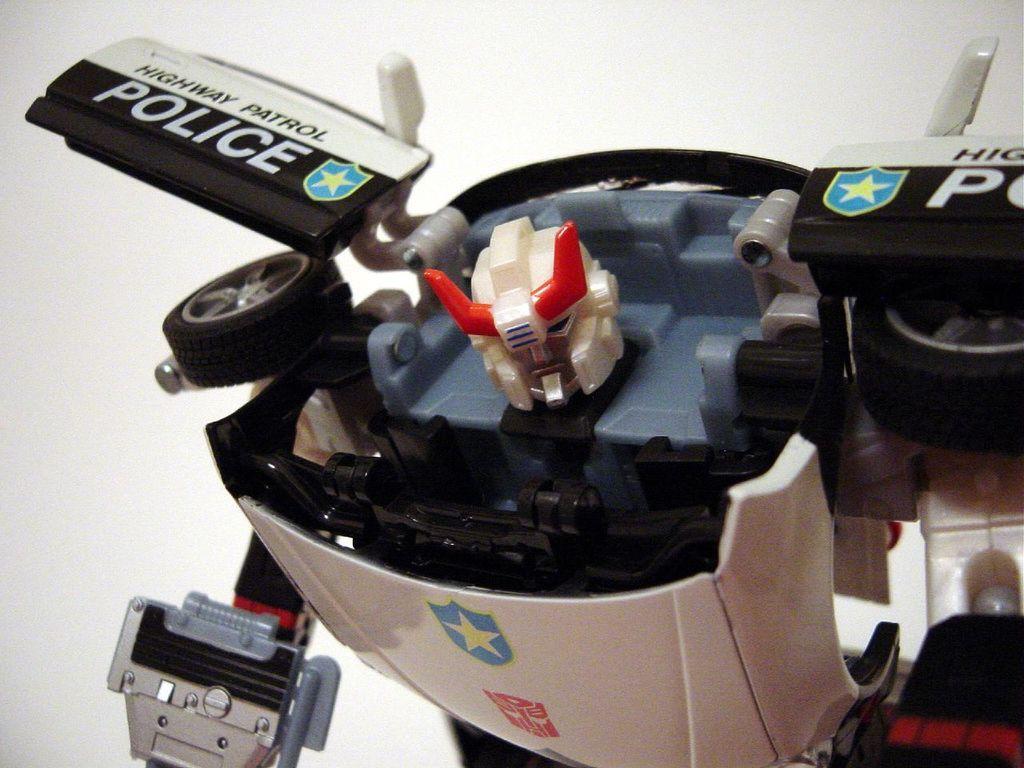In one or two sentences, can you explain what this image depicts? In the image we can see a robot, this is a printed text. 